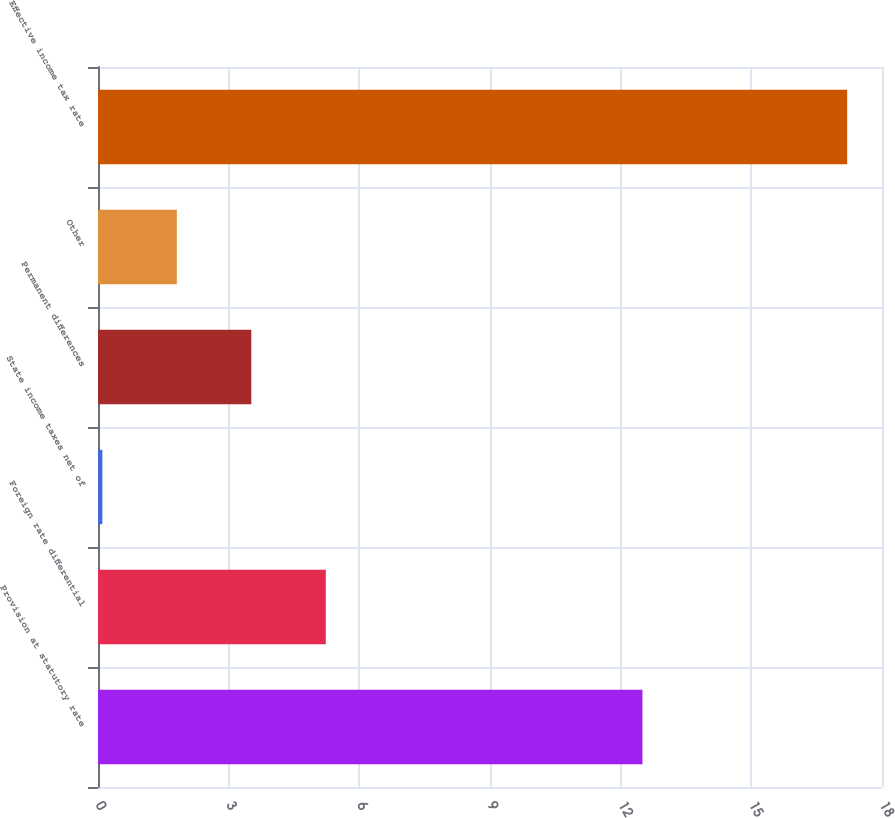Convert chart. <chart><loc_0><loc_0><loc_500><loc_500><bar_chart><fcel>Provision at statutory rate<fcel>Foreign rate differential<fcel>State income taxes net of<fcel>Permanent differences<fcel>Other<fcel>Effective income tax rate<nl><fcel>12.5<fcel>5.23<fcel>0.1<fcel>3.52<fcel>1.81<fcel>17.2<nl></chart> 